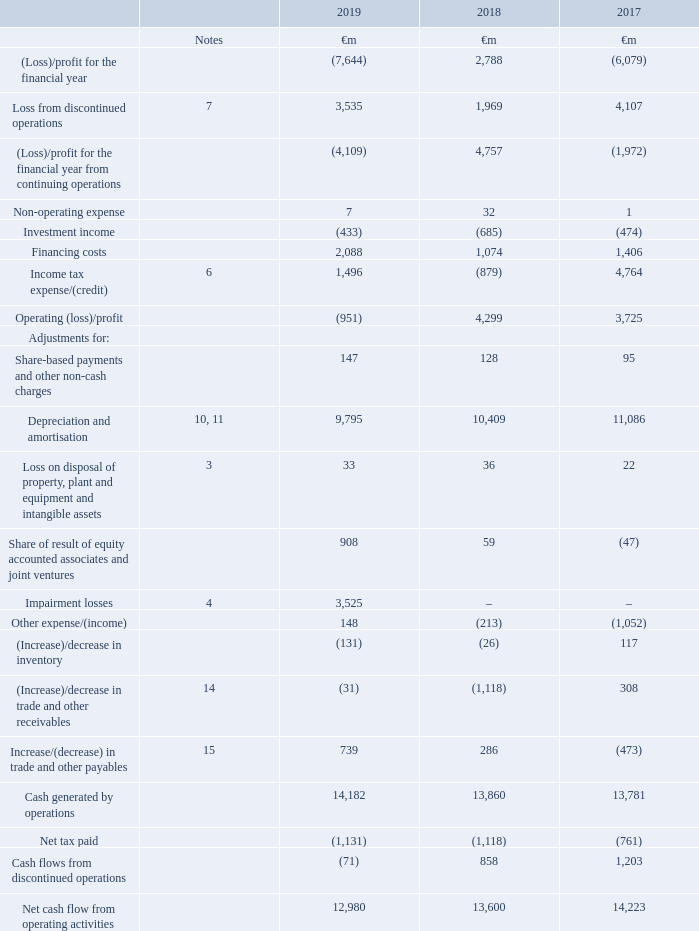18. Reconciliation of net cash flow from operating activities
The table below shows how our (loss)/profit for the year from continuing operations translates into cash flows generated from our operating activities.
What does the table below show? How our (loss)/profit for the year from continuing operations translates into cash flows generated from our operating activities. How much is the 2019 net tax?
Answer scale should be: million. 1,131. How much is the 2018 net tax paid?
Answer scale should be: million. 1,118. What is the average net cash flow from operating activities between 2018 and 2019?
Answer scale should be: million. (12,980+13,600)/2
Answer: 13290. What is the average net cash flow from operating activities between 2017 and 2018?
Answer scale should be: million. (13,600+14,223)/2
Answer: 13911.5. What is the change of average net cash flow from operating activities between 2017-2018 and 2018-2019?
Answer scale should be: million. [(12,980+13,600)/2] - [(13,600+14,223)/2]
Answer: -621.5. 